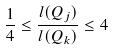<formula> <loc_0><loc_0><loc_500><loc_500>\frac { 1 } { 4 } \leq \frac { l ( Q _ { j } ) } { l ( Q _ { k } ) } \leq 4</formula> 